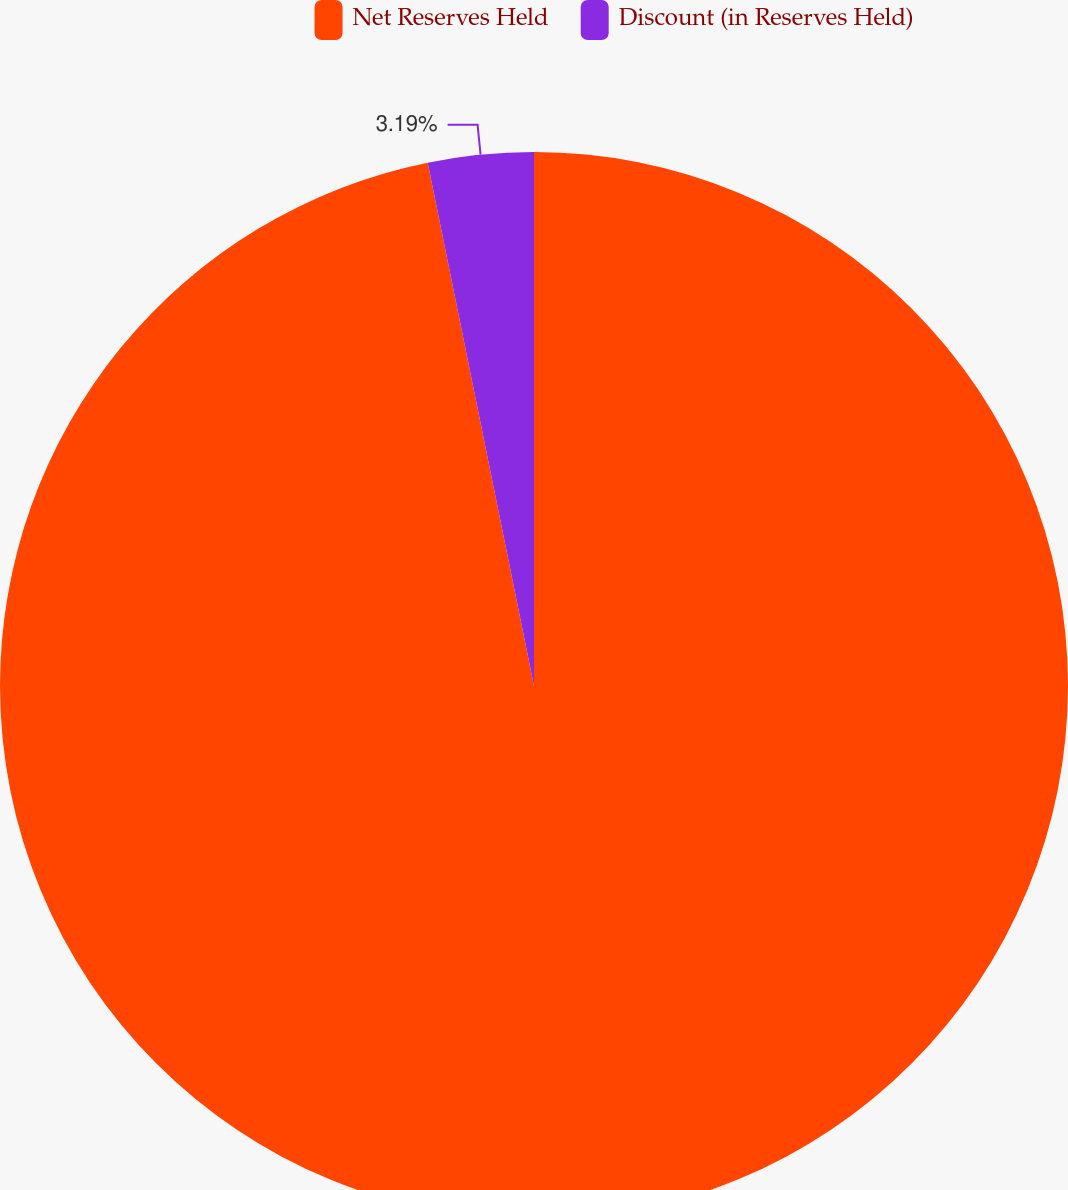Convert chart. <chart><loc_0><loc_0><loc_500><loc_500><pie_chart><fcel>Net Reserves Held<fcel>Discount (in Reserves Held)<nl><fcel>96.81%<fcel>3.19%<nl></chart> 